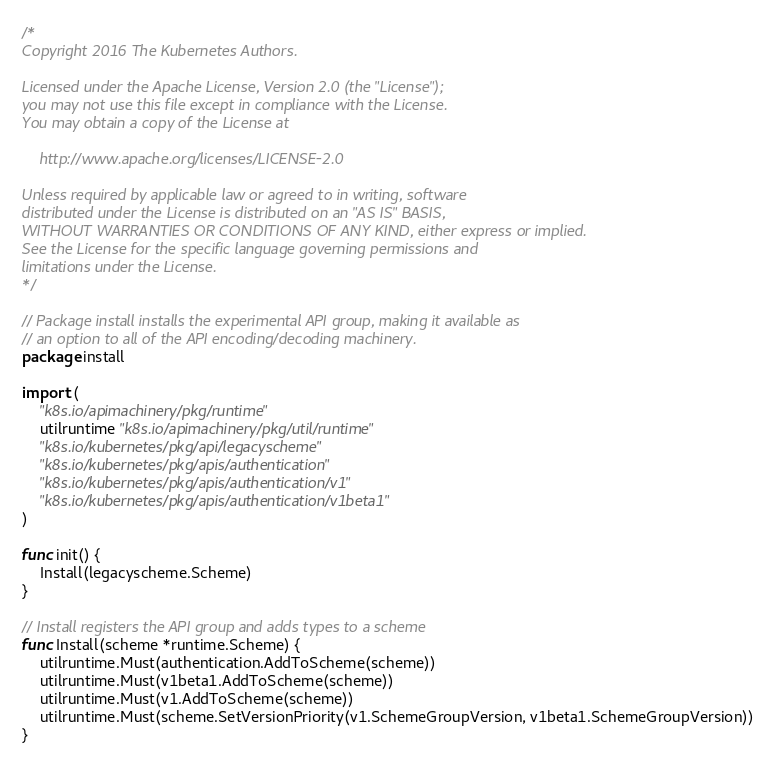Convert code to text. <code><loc_0><loc_0><loc_500><loc_500><_Go_>/*
Copyright 2016 The Kubernetes Authors.

Licensed under the Apache License, Version 2.0 (the "License");
you may not use this file except in compliance with the License.
You may obtain a copy of the License at

    http://www.apache.org/licenses/LICENSE-2.0

Unless required by applicable law or agreed to in writing, software
distributed under the License is distributed on an "AS IS" BASIS,
WITHOUT WARRANTIES OR CONDITIONS OF ANY KIND, either express or implied.
See the License for the specific language governing permissions and
limitations under the License.
*/

// Package install installs the experimental API group, making it available as
// an option to all of the API encoding/decoding machinery.
package install

import (
	"k8s.io/apimachinery/pkg/runtime"
	utilruntime "k8s.io/apimachinery/pkg/util/runtime"
	"k8s.io/kubernetes/pkg/api/legacyscheme"
	"k8s.io/kubernetes/pkg/apis/authentication"
	"k8s.io/kubernetes/pkg/apis/authentication/v1"
	"k8s.io/kubernetes/pkg/apis/authentication/v1beta1"
)

func init() {
	Install(legacyscheme.Scheme)
}

// Install registers the API group and adds types to a scheme
func Install(scheme *runtime.Scheme) {
	utilruntime.Must(authentication.AddToScheme(scheme))
	utilruntime.Must(v1beta1.AddToScheme(scheme))
	utilruntime.Must(v1.AddToScheme(scheme))
	utilruntime.Must(scheme.SetVersionPriority(v1.SchemeGroupVersion, v1beta1.SchemeGroupVersion))
}
</code> 